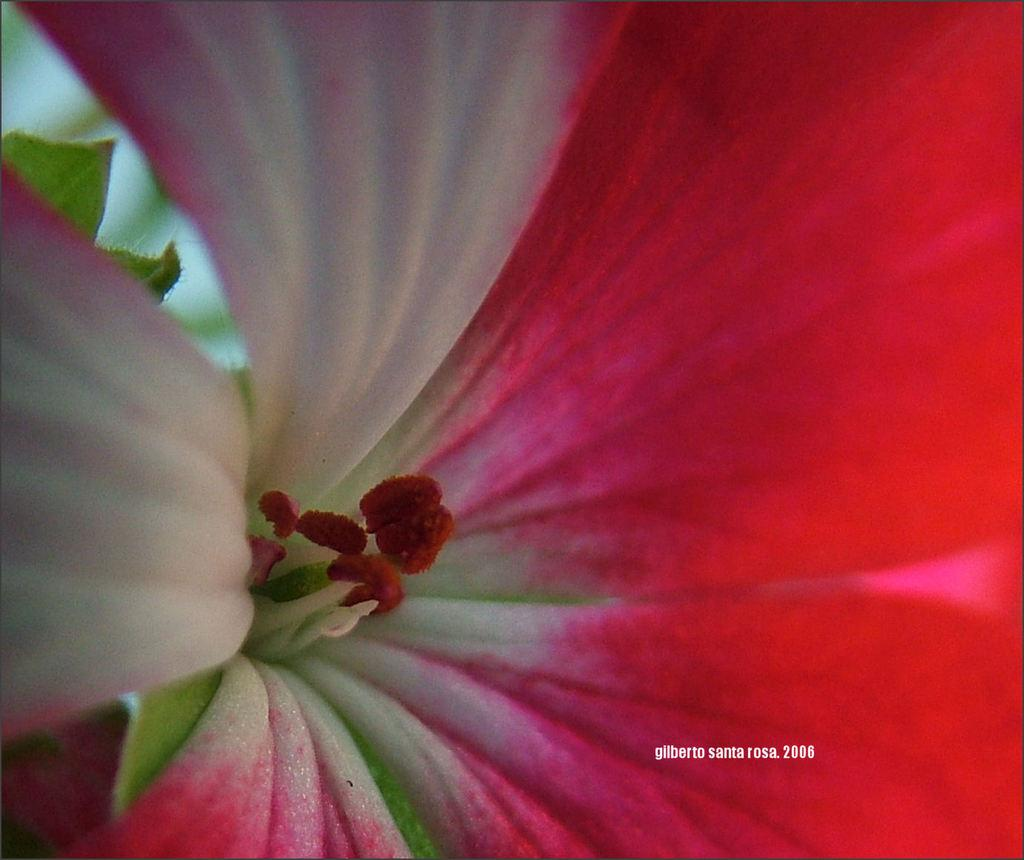What is the main subject of the image? There is a flower in the image. What else can be seen in the image besides the flower? Part of leaves are visible in the image. How would you describe the background of the image? The background is blurred. Is there any additional information or marking on the image? Yes, there is a watermark on the image. What type of wood is used to make the truck's wheels in the image? There is no truck present in the image, so it is not possible to determine the type of wood used for its wheels. 